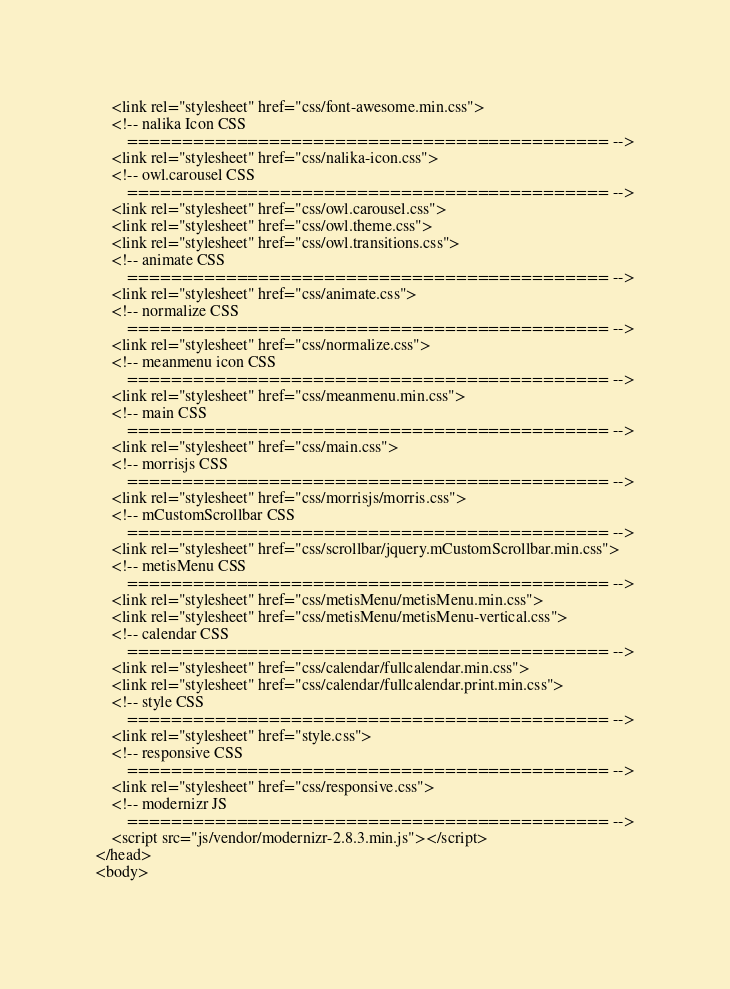Convert code to text. <code><loc_0><loc_0><loc_500><loc_500><_PHP_>    <link rel="stylesheet" href="css/font-awesome.min.css">
	<!-- nalika Icon CSS
		============================================ -->
    <link rel="stylesheet" href="css/nalika-icon.css">
    <!-- owl.carousel CSS
		============================================ -->
    <link rel="stylesheet" href="css/owl.carousel.css">
    <link rel="stylesheet" href="css/owl.theme.css">
    <link rel="stylesheet" href="css/owl.transitions.css">
    <!-- animate CSS
		============================================ -->
    <link rel="stylesheet" href="css/animate.css">
    <!-- normalize CSS
		============================================ -->
    <link rel="stylesheet" href="css/normalize.css">
    <!-- meanmenu icon CSS
		============================================ -->
    <link rel="stylesheet" href="css/meanmenu.min.css">
    <!-- main CSS
		============================================ -->
    <link rel="stylesheet" href="css/main.css">
    <!-- morrisjs CSS
		============================================ -->
    <link rel="stylesheet" href="css/morrisjs/morris.css">
    <!-- mCustomScrollbar CSS
		============================================ -->
    <link rel="stylesheet" href="css/scrollbar/jquery.mCustomScrollbar.min.css">
    <!-- metisMenu CSS
		============================================ -->
    <link rel="stylesheet" href="css/metisMenu/metisMenu.min.css">
    <link rel="stylesheet" href="css/metisMenu/metisMenu-vertical.css">
    <!-- calendar CSS
		============================================ -->
    <link rel="stylesheet" href="css/calendar/fullcalendar.min.css">
    <link rel="stylesheet" href="css/calendar/fullcalendar.print.min.css">
    <!-- style CSS
		============================================ -->
    <link rel="stylesheet" href="style.css">
    <!-- responsive CSS
		============================================ -->
    <link rel="stylesheet" href="css/responsive.css">
    <!-- modernizr JS
		============================================ -->
    <script src="js/vendor/modernizr-2.8.3.min.js"></script>
</head>
<body>
  </code> 